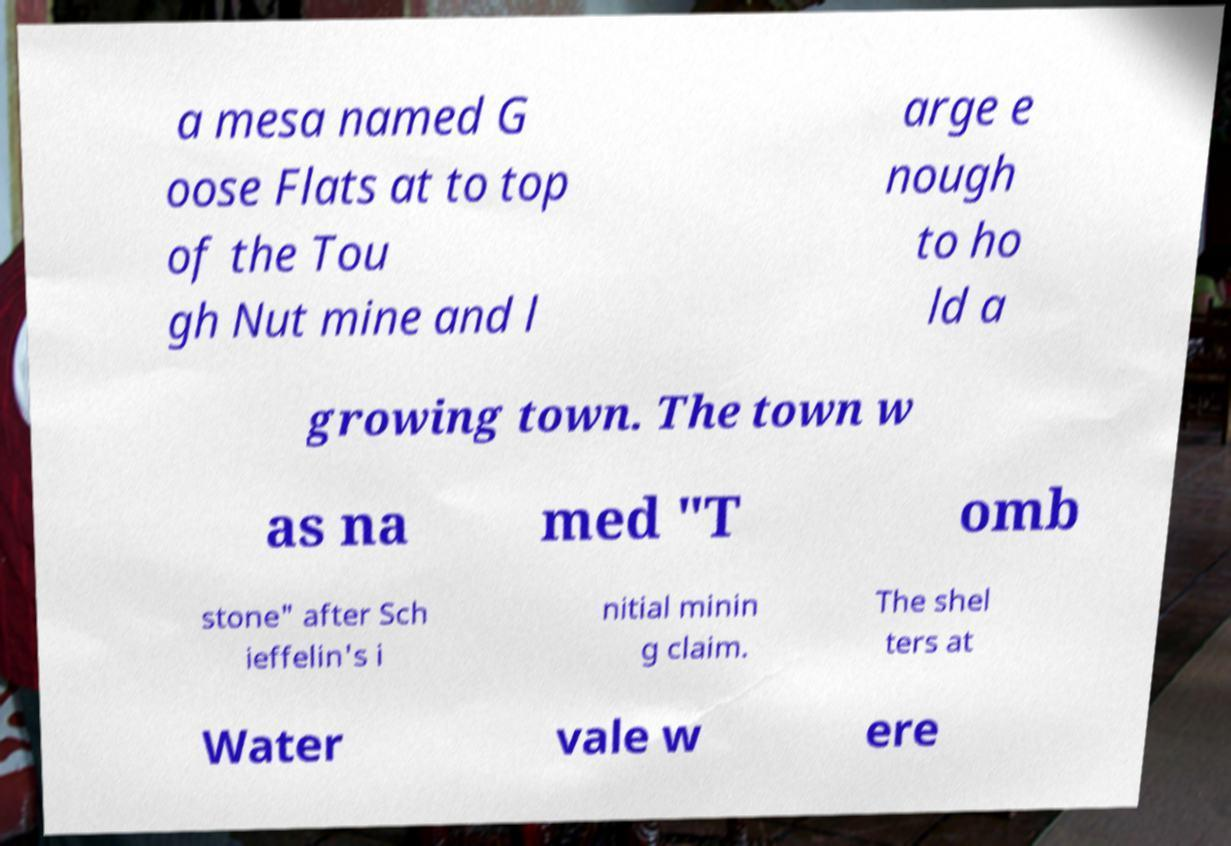Can you accurately transcribe the text from the provided image for me? a mesa named G oose Flats at to top of the Tou gh Nut mine and l arge e nough to ho ld a growing town. The town w as na med "T omb stone" after Sch ieffelin's i nitial minin g claim. The shel ters at Water vale w ere 